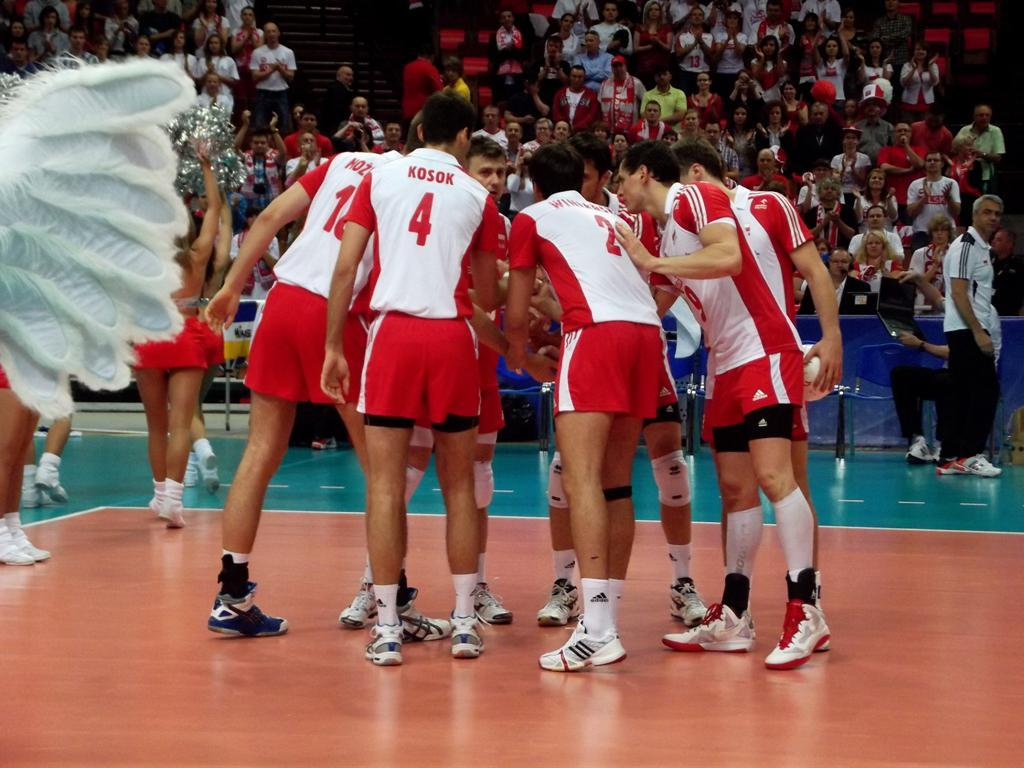<image>
Summarize the visual content of the image. A group of male basketball players with red Jerseys that say Kosok are huddling during a game. 